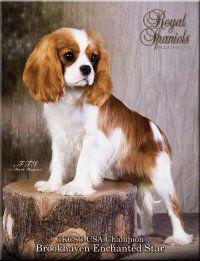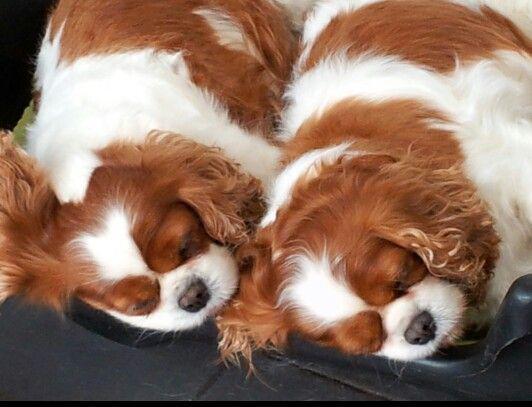The first image is the image on the left, the second image is the image on the right. Assess this claim about the two images: "The left image has no more than one dog laying down.". Correct or not? Answer yes or no. No. The first image is the image on the left, the second image is the image on the right. Assess this claim about the two images: "In one of the image there are puppies near an adult dog.". Correct or not? Answer yes or no. No. 